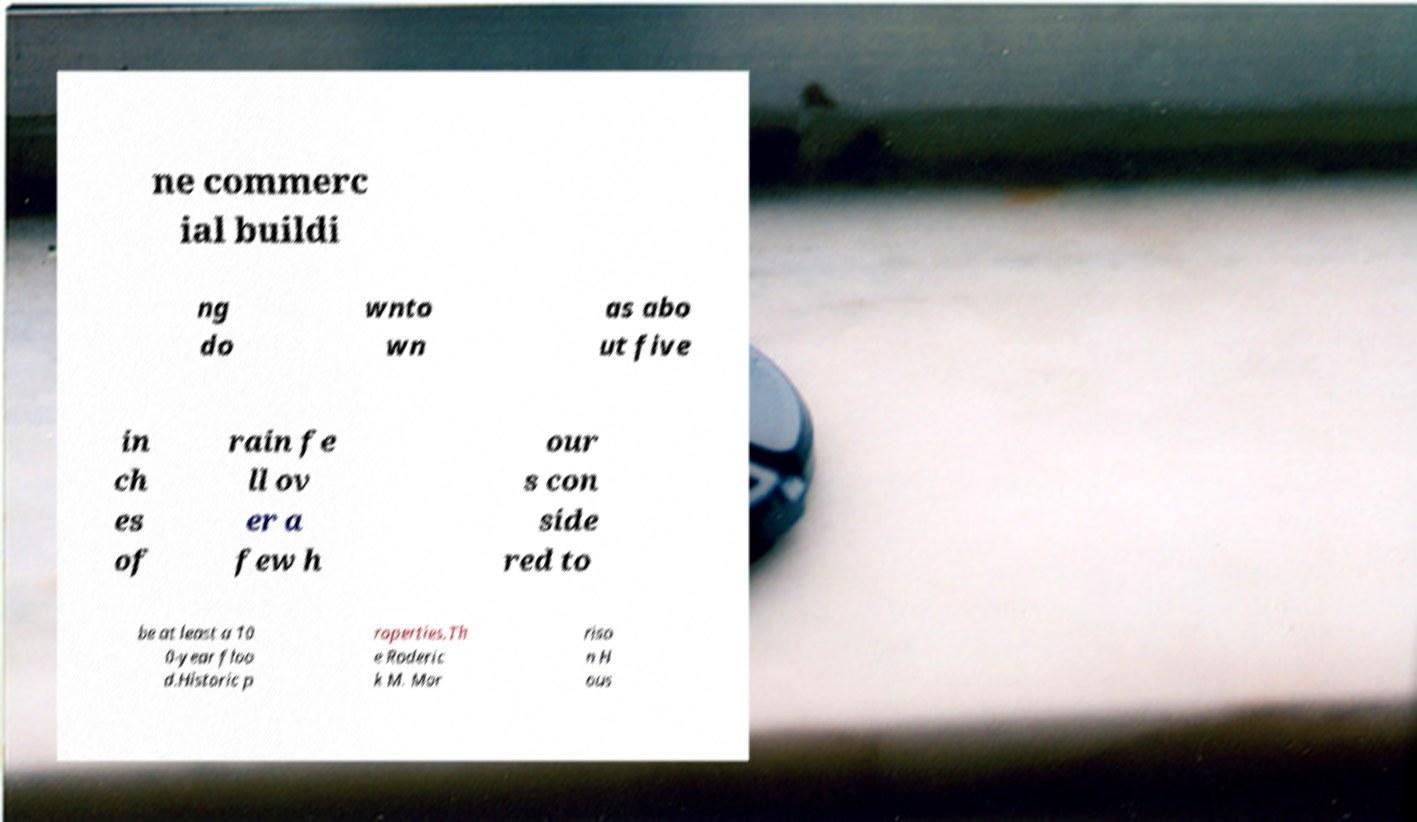Can you accurately transcribe the text from the provided image for me? ne commerc ial buildi ng do wnto wn as abo ut five in ch es of rain fe ll ov er a few h our s con side red to be at least a 10 0-year floo d.Historic p roperties.Th e Roderic k M. Mor riso n H ous 